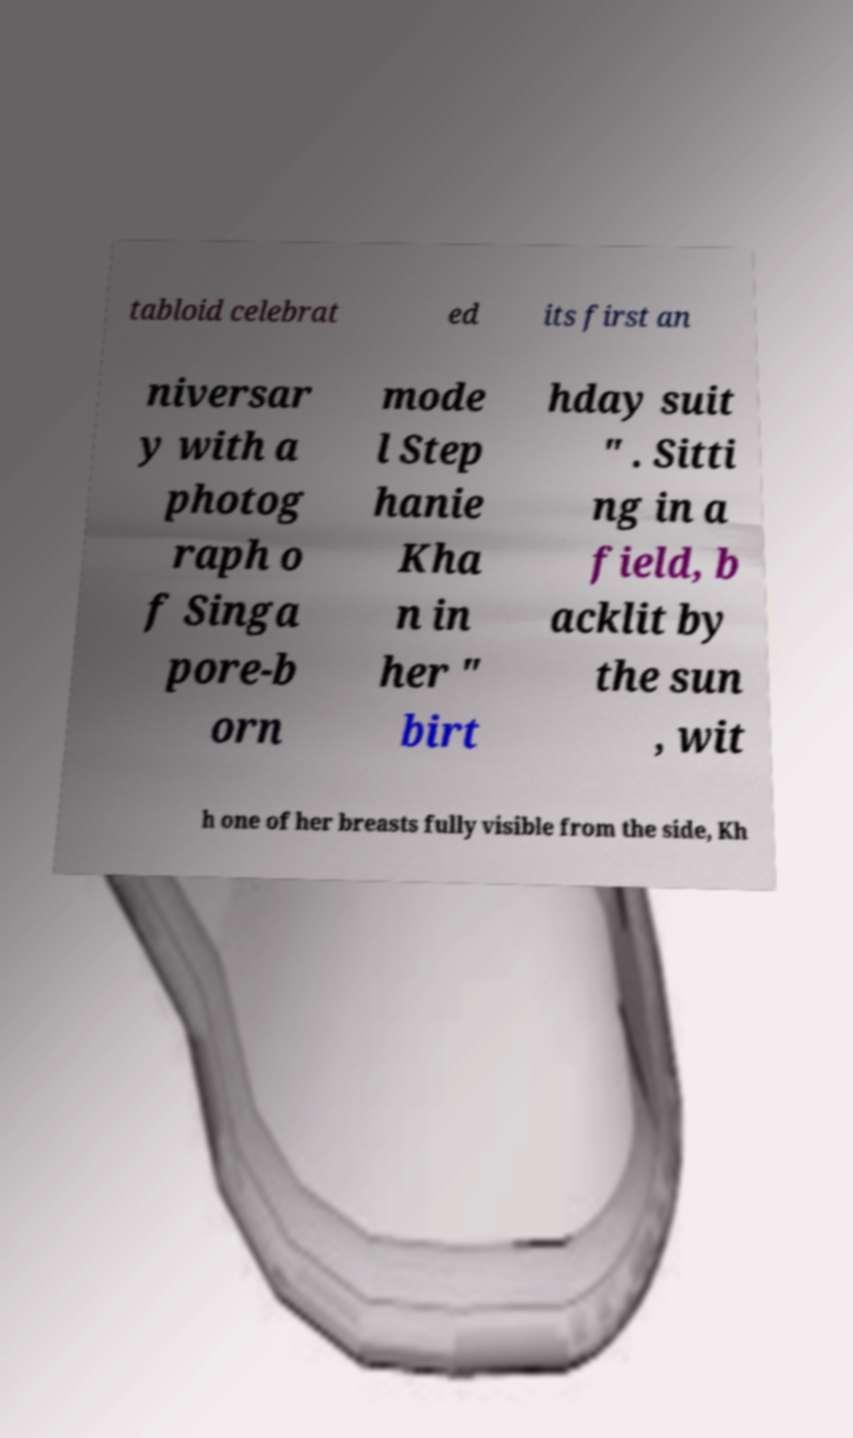For documentation purposes, I need the text within this image transcribed. Could you provide that? tabloid celebrat ed its first an niversar y with a photog raph o f Singa pore-b orn mode l Step hanie Kha n in her " birt hday suit " . Sitti ng in a field, b acklit by the sun , wit h one of her breasts fully visible from the side, Kh 